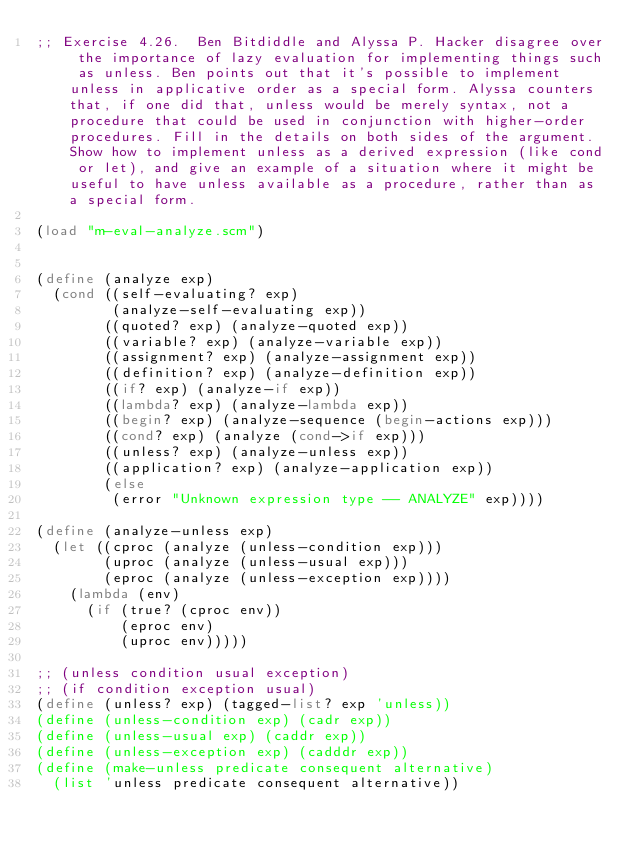Convert code to text. <code><loc_0><loc_0><loc_500><loc_500><_Scheme_>;; Exercise 4.26.  Ben Bitdiddle and Alyssa P. Hacker disagree over the importance of lazy evaluation for implementing things such as unless. Ben points out that it's possible to implement unless in applicative order as a special form. Alyssa counters that, if one did that, unless would be merely syntax, not a procedure that could be used in conjunction with higher-order procedures. Fill in the details on both sides of the argument. Show how to implement unless as a derived expression (like cond or let), and give an example of a situation where it might be useful to have unless available as a procedure, rather than as a special form.

(load "m-eval-analyze.scm")


(define (analyze exp)
  (cond ((self-evaluating? exp)
         (analyze-self-evaluating exp))
        ((quoted? exp) (analyze-quoted exp))
        ((variable? exp) (analyze-variable exp))
        ((assignment? exp) (analyze-assignment exp))
        ((definition? exp) (analyze-definition exp))
        ((if? exp) (analyze-if exp))
        ((lambda? exp) (analyze-lambda exp))
        ((begin? exp) (analyze-sequence (begin-actions exp)))
        ((cond? exp) (analyze (cond->if exp)))
        ((unless? exp) (analyze-unless exp))
        ((application? exp) (analyze-application exp))
        (else
         (error "Unknown expression type -- ANALYZE" exp))))

(define (analyze-unless exp)
  (let ((cproc (analyze (unless-condition exp)))
        (uproc (analyze (unless-usual exp)))
        (eproc (analyze (unless-exception exp))))
    (lambda (env)
      (if (true? (cproc env))
          (eproc env)
          (uproc env)))))

;; (unless condition usual exception)
;; (if condition exception usual)
(define (unless? exp) (tagged-list? exp 'unless))
(define (unless-condition exp) (cadr exp))
(define (unless-usual exp) (caddr exp))
(define (unless-exception exp) (cadddr exp))
(define (make-unless predicate consequent alternative)
  (list 'unless predicate consequent alternative))
</code> 